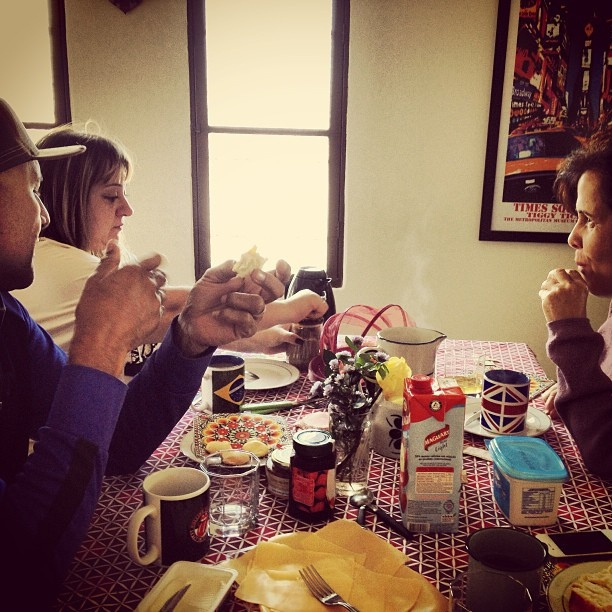Describe the objects in this image and their specific colors. I can see dining table in tan, black, maroon, and brown tones, people in tan, black, brown, and maroon tones, people in tan, black, maroon, and brown tones, people in tan, black, and brown tones, and cup in tan, black, gray, and maroon tones in this image. 